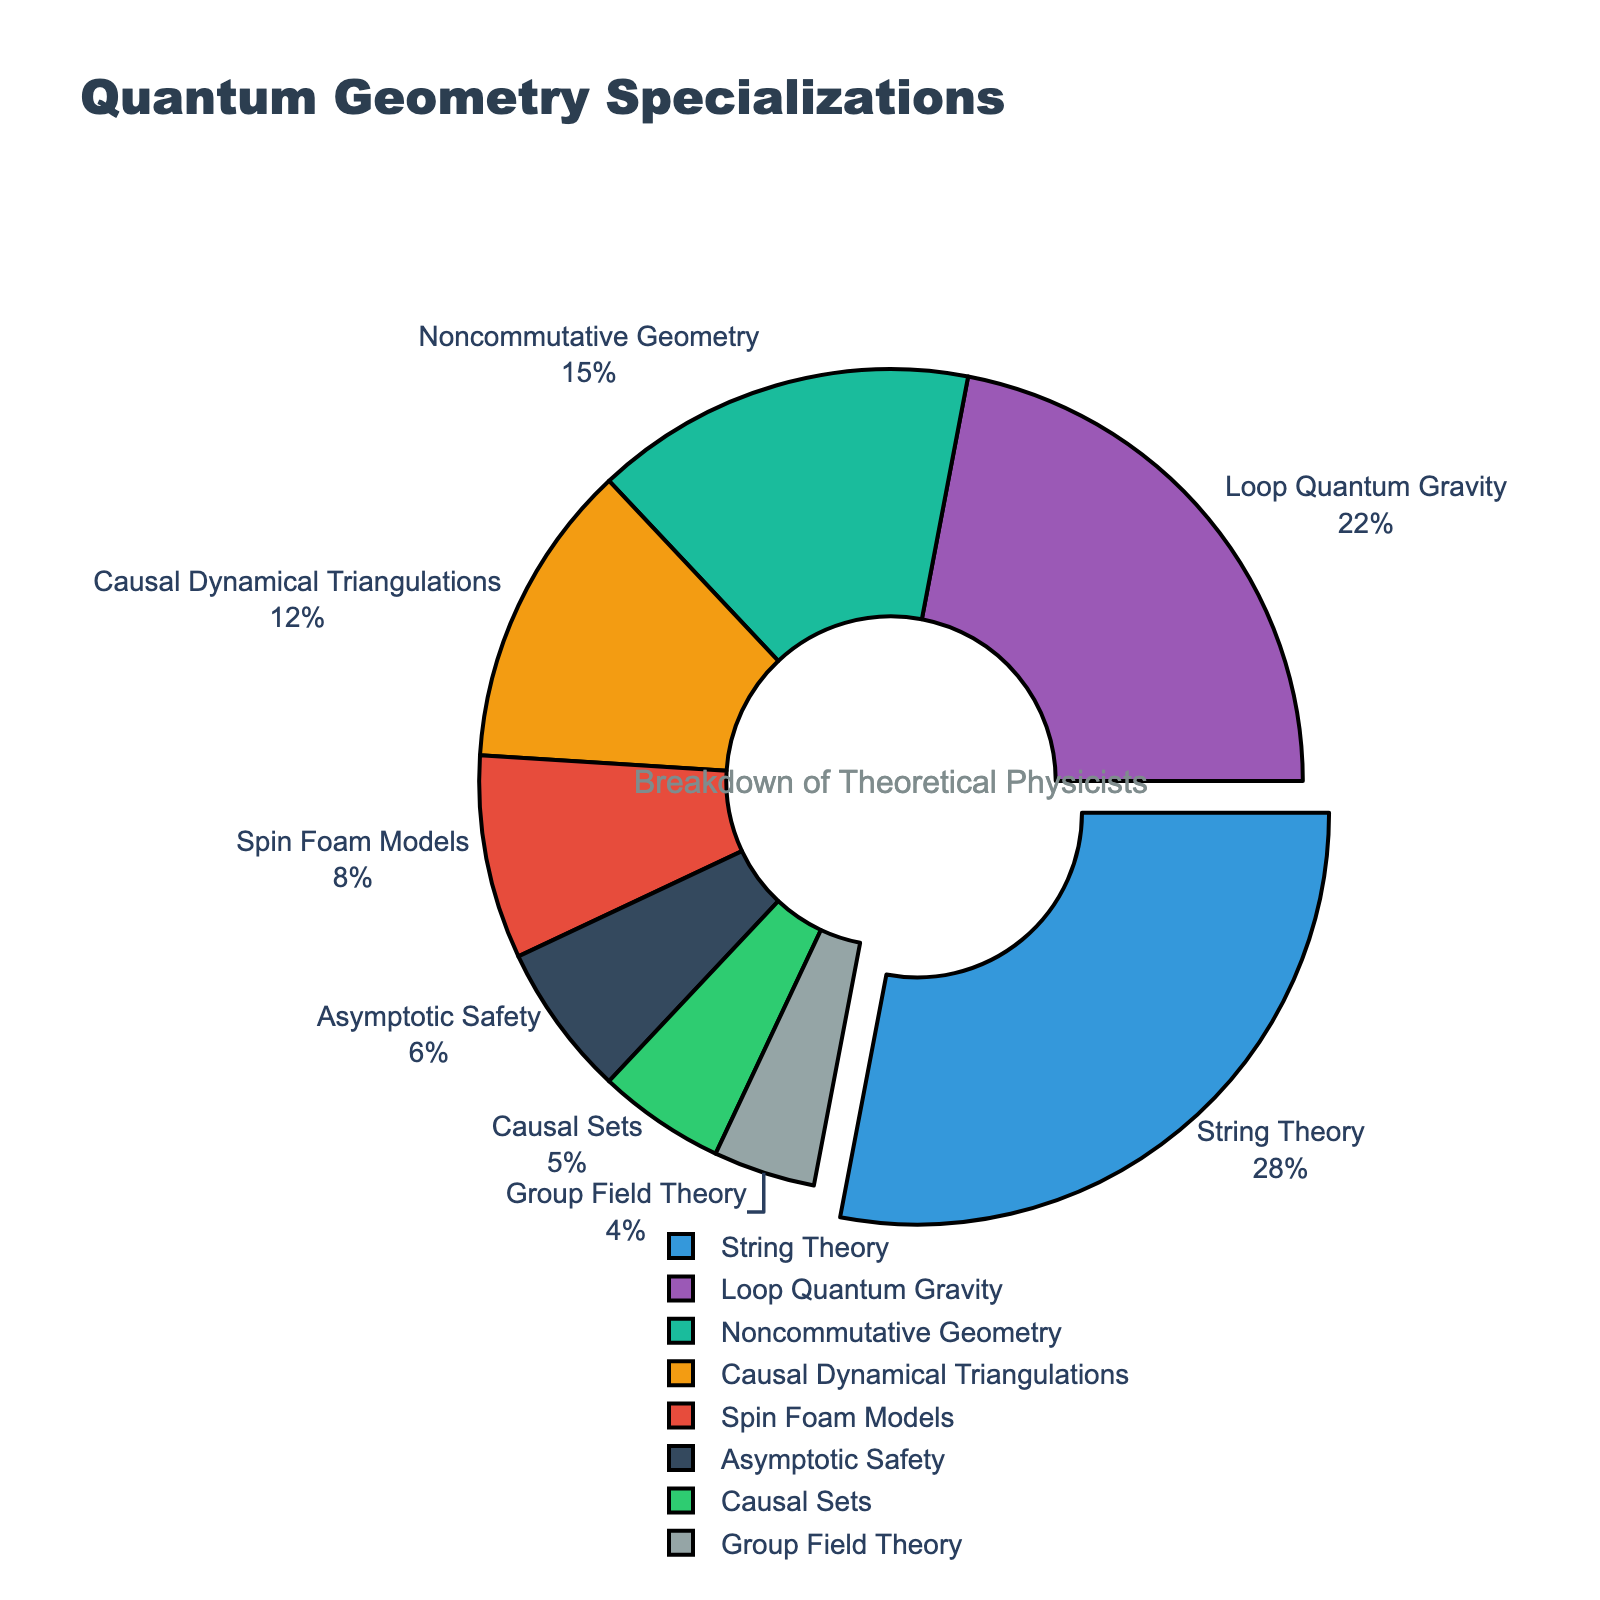What specialization has the highest percentage of theoretical physicists? The figure shows various percentages of physicists in different areas of quantum geometry. The largest portion is pulled out from the rest and is marked with both its label and percentage.
Answer: String Theory How much more percentage does String Theory have compared to Asymptotic Safety? By visually comparing the percentages, we see that String Theory has 28% and Asymptotic Safety has 6%. Subtracting these gives the difference. 28% - 6% = 22%.
Answer: 22% What is the combined percentage of physicists specializing in Loop Quantum Gravity and Spin Foam Models? We find the percentages for Loop Quantum Gravity and Spin Foam Models, which are 22% and 8%, respectively, and add them together. 22% + 8% = 30%.
Answer: 30% Is there a larger proportion of physicists in Noncommutative Geometry or Causal Sets? Comparing the percentages visually, Noncommutative Geometry has 15% and Causal Sets has 5%. Since 15% > 5%, Noncommutative Geometry has a larger proportion.
Answer: Noncommutative Geometry What is the second most common area of specialization among theoretical physicists? The pie chart shows various percentages, and after String Theory (28%), the next largest segment is Loop Quantum Gravity with 22%.
Answer: Loop Quantum Gravity Which color corresponds to the segment representing Causal Dynamical Triangulations? By looking at the colors in the pie chart and their corresponding labels, we find that the segment for Causal Dynamical Triangulations is represented by the color orange.
Answer: Orange How much total percentage do String Theory and Noncommutative Geometry cover together? Adding the percentages of String Theory (28%) and Noncommutative Geometry (15%) gives us 28% + 15% = 43%.
Answer: 43% What is the percentage difference between Causal Dynamical Triangulations and Group Field Theory? Causal Dynamical Triangulations has 12% and Group Field Theory has 4%. Subtracting these gives 12% - 4% = 8%.
Answer: 8% Which has a smaller percentage: Causal Sets or Asymptotic Safety? Comparing their percentages visually, Causal Sets has 5% and Asymptotic Safety has 6%, so Causal Sets has a smaller percentage.
Answer: Causal Sets What is the approximate percentage of physicists not specializing in String Theory? To find this, subtract the percentage of String Theory from 100%. 100% - 28% = 72%.
Answer: 72% 